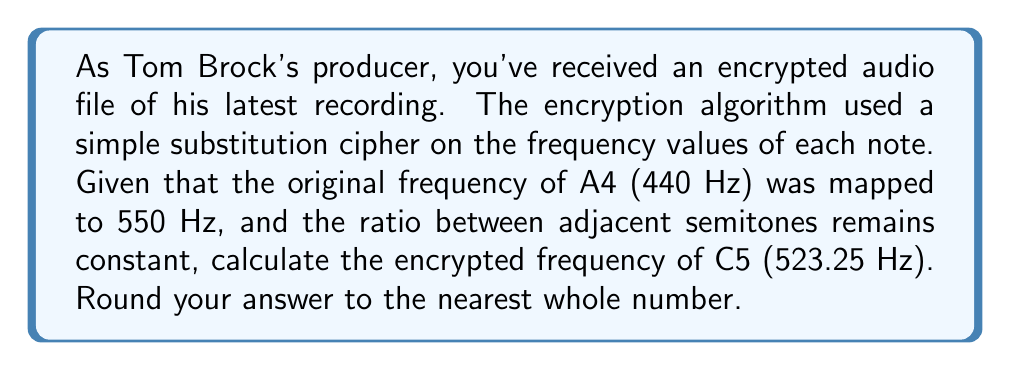Show me your answer to this math problem. Let's approach this step-by-step:

1) In the equal temperament system, the ratio between the frequencies of adjacent semitones is constant and equal to $\sqrt[12]{2}$.

2) A4 to C5 is 3 semitones apart. So the ratio of their frequencies is:

   $$(\sqrt[12]{2})^3 = \sqrt[4]{2} \approx 1.189207115$$

3) We can express this relationship as:

   $$\frac{f_{C5}}{f_{A4}} = \sqrt[4]{2}$$

4) We know that in the original recording:
   $f_{A4} = 440$ Hz and $f_{C5} = 523.25$ Hz

5) In the encrypted version, $f_{A4}' = 550$ Hz. Let's call the encrypted frequency of C5 $f_{C5}'$.

6) The encryption maintains the ratio between notes, so:

   $$\frac{f_{C5}'}{550} = \frac{523.25}{440}$$

7) Solving for $f_{C5}'$:

   $$f_{C5}' = 550 \cdot \frac{523.25}{440} = 654.0625$$

8) Rounding to the nearest whole number:

   $$f_{C5}' \approx 654 \text{ Hz}$$
Answer: 654 Hz 